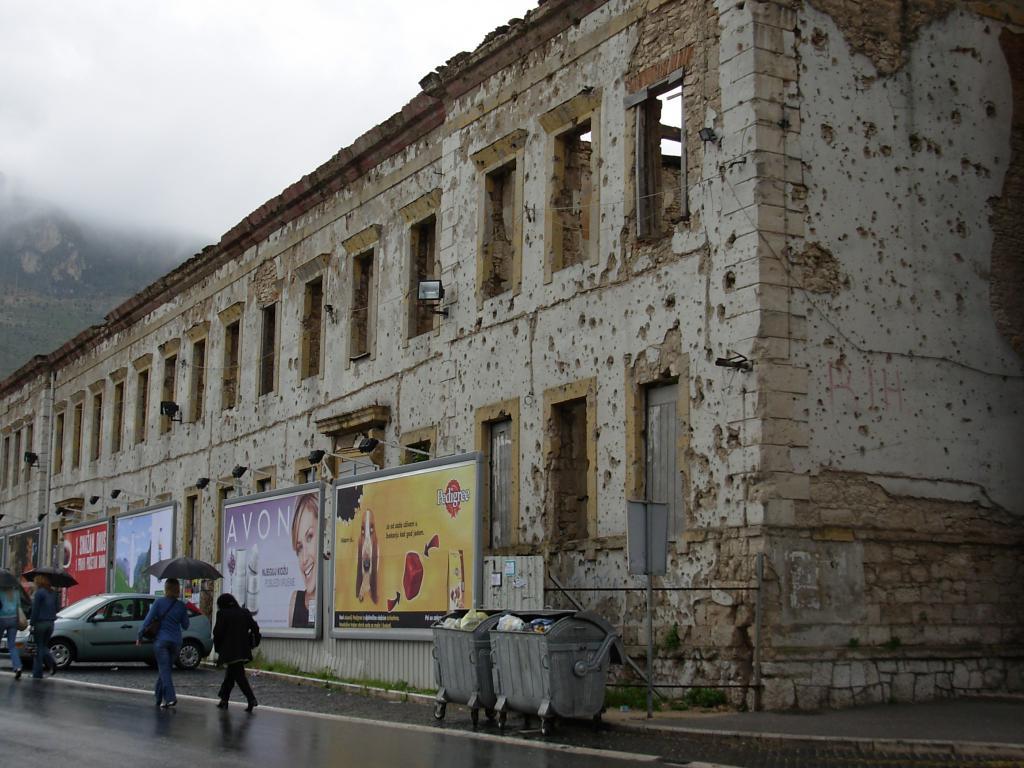What is the company name on the middle sign?
Keep it short and to the point. Avon. 